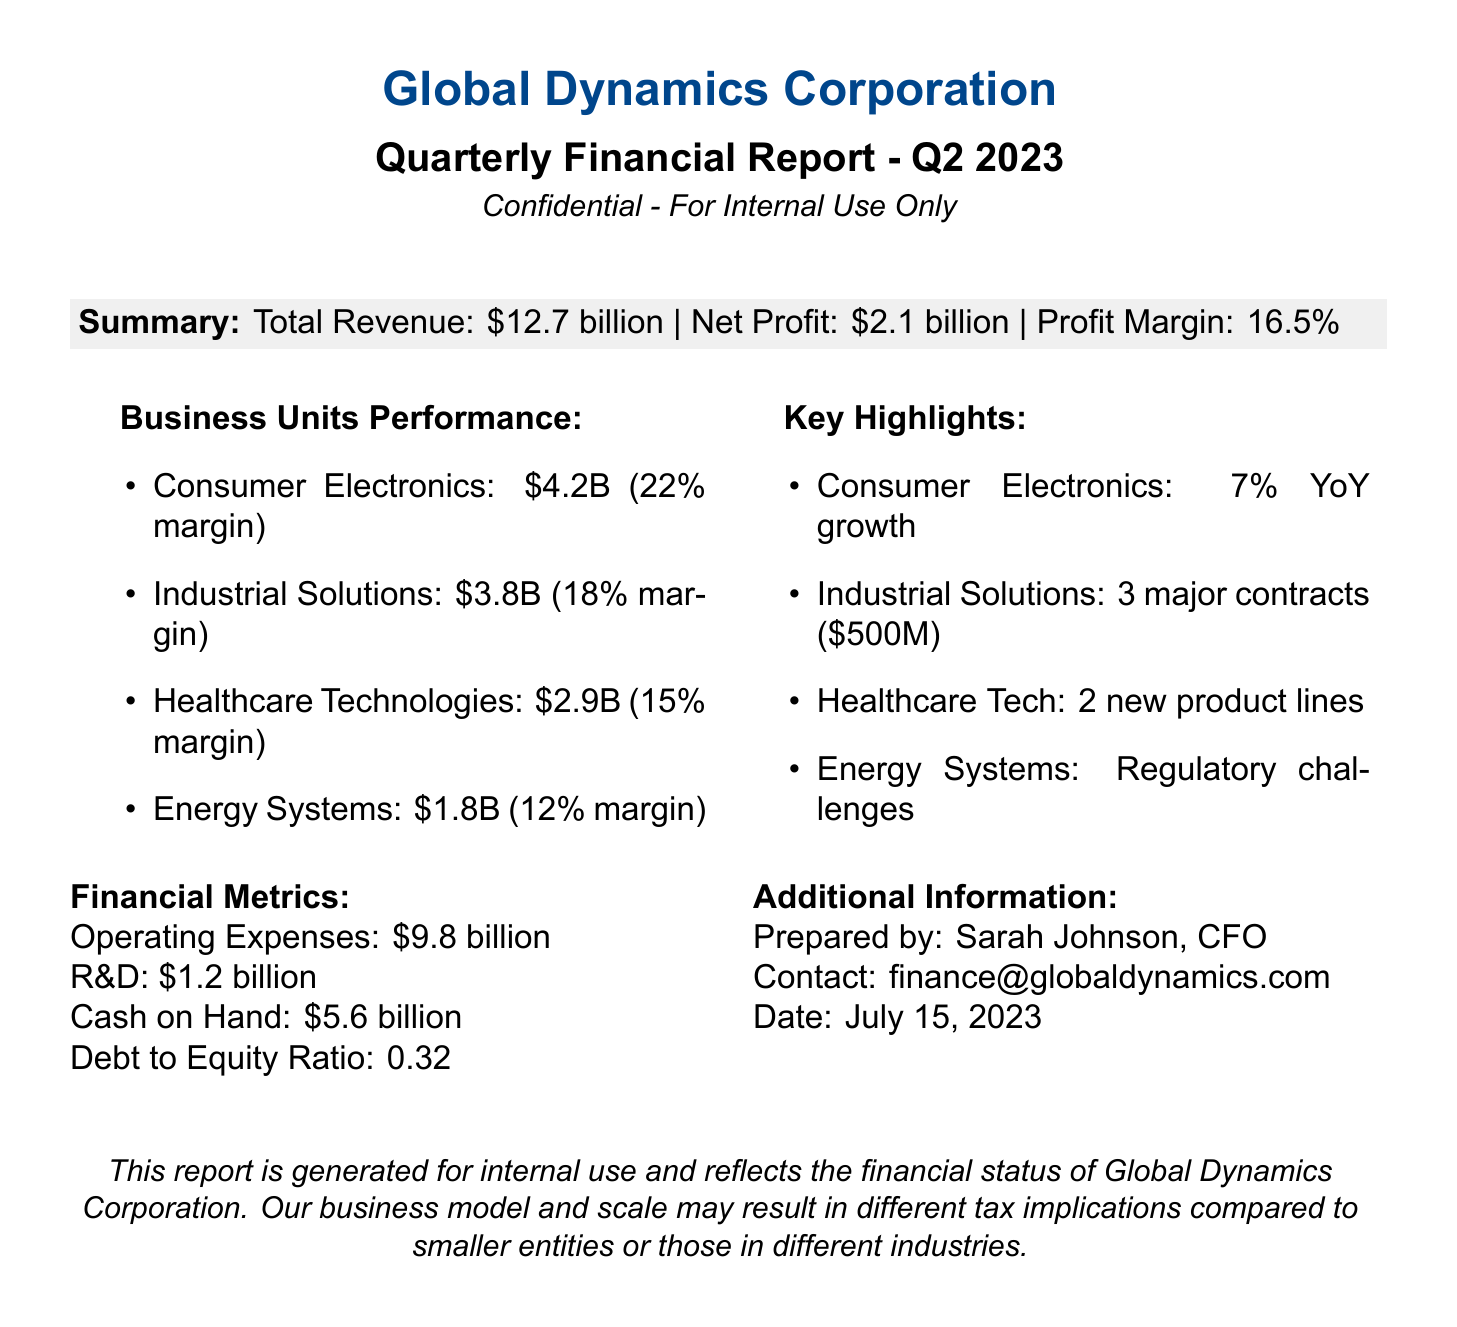What is the total revenue? The total revenue is provided as a summary in the document, amounting to $12.7 billion.
Answer: $12.7 billion What is the net profit? The net profit is also mentioned in the summary section of the document, which is $2.1 billion.
Answer: $2.1 billion What is the profit margin? The profit margin is stated as 16.5% in the summary.
Answer: 16.5% Which business unit generated the highest revenue? The business unit with the highest revenue is Consumer Electronics, with \$4.2 billion.
Answer: Consumer Electronics How many major contracts did Industrial Solutions acquire? The document mentions that Industrial Solutions secured 3 major contracts.
Answer: 3 What was the year's growth percentage for Consumer Electronics? Consumer Electronics saw a growth of 7% year over year (YoY).
Answer: 7% Who prepared the financial report? The report lists Sarah Johnson as the preparer.
Answer: Sarah Johnson What is the date of the report? The report specifies the date as July 15, 2023.
Answer: July 15, 2023 What was the cash on hand amount? The document states that the cash on hand is \$5.6 billion.
Answer: $5.6 billion What regulatory issue is mentioned for Energy Systems? The report notes that Energy Systems is facing regulatory challenges.
Answer: Regulatory challenges 